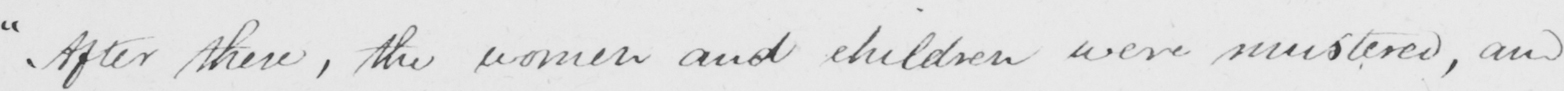Transcribe the text shown in this historical manuscript line. " After then , the women and children were mustered , and 